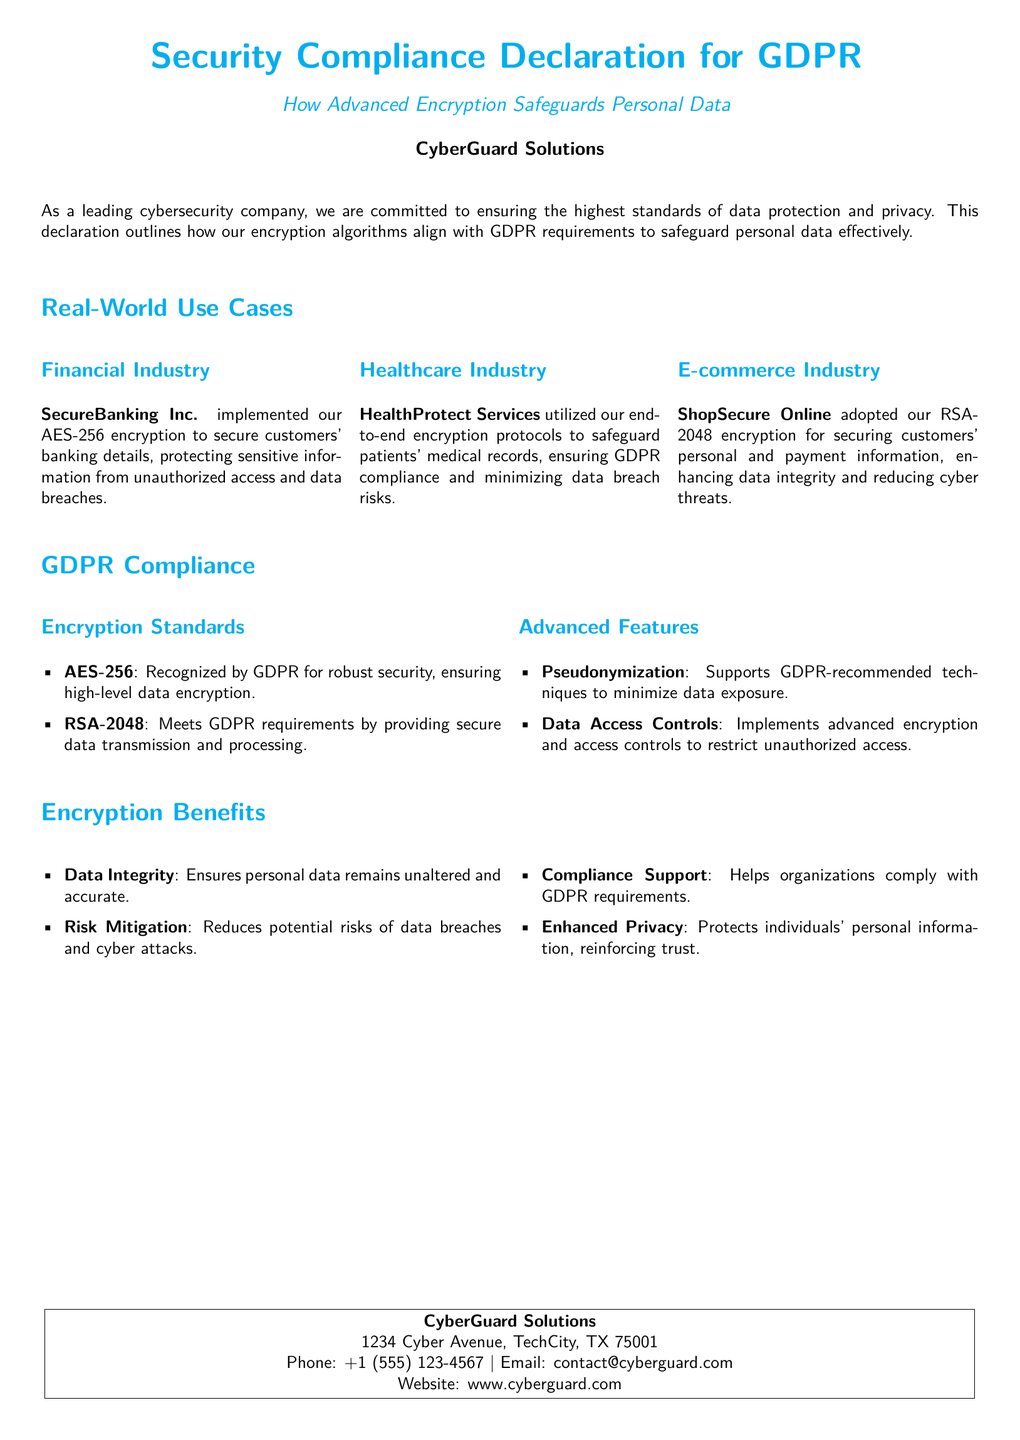What is the title of the document? The title of the document is found at the top section and identifies the subject matter clearly.
Answer: Security Compliance Declaration for GDPR Which encryption standard is recognized by GDPR for robust security? The document states specific encryption standards acknowledged by GDPR for high-level encryption, highlighting one in particular.
Answer: AES-256 What is a key feature mentioned for GDPR compliance in the document? The document outlines advanced features related to GDPR compliance and identifies a support technique.
Answer: Pseudonymization Who is the company behind the declaration? The document clearly identifies the company responsible for the declaration, listed prominently at the end.
Answer: CyberGuard Solutions Which industry used AES-256 encryption according to the use cases? The document lists various industries and associates one specifically with the use of AES-256 encryption.
Answer: Financial Industry How does the document describe the benefit of data integrity? The document includes benefits of encryption, ensuring data remains unaltered, which is a specific benefit mentioned.
Answer: Ensures personal data remains unaltered and accurate What is the address of CyberGuard Solutions? The contact details section provides the physical location of the company, which is necessary for communication purposes.
Answer: 1234 Cyber Avenue, TechCity, TX 75001 What type of encryption does ShopSecure Online use? The document details the specific encryption methods adopted by companies within various industries, including one named here.
Answer: RSA-2048 